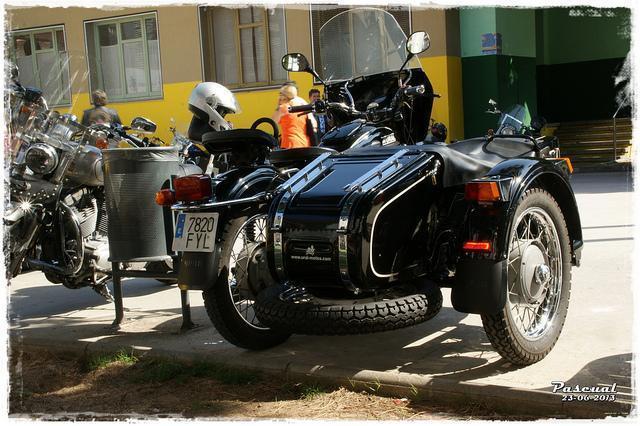How many motorcycles can you see?
Give a very brief answer. 3. 